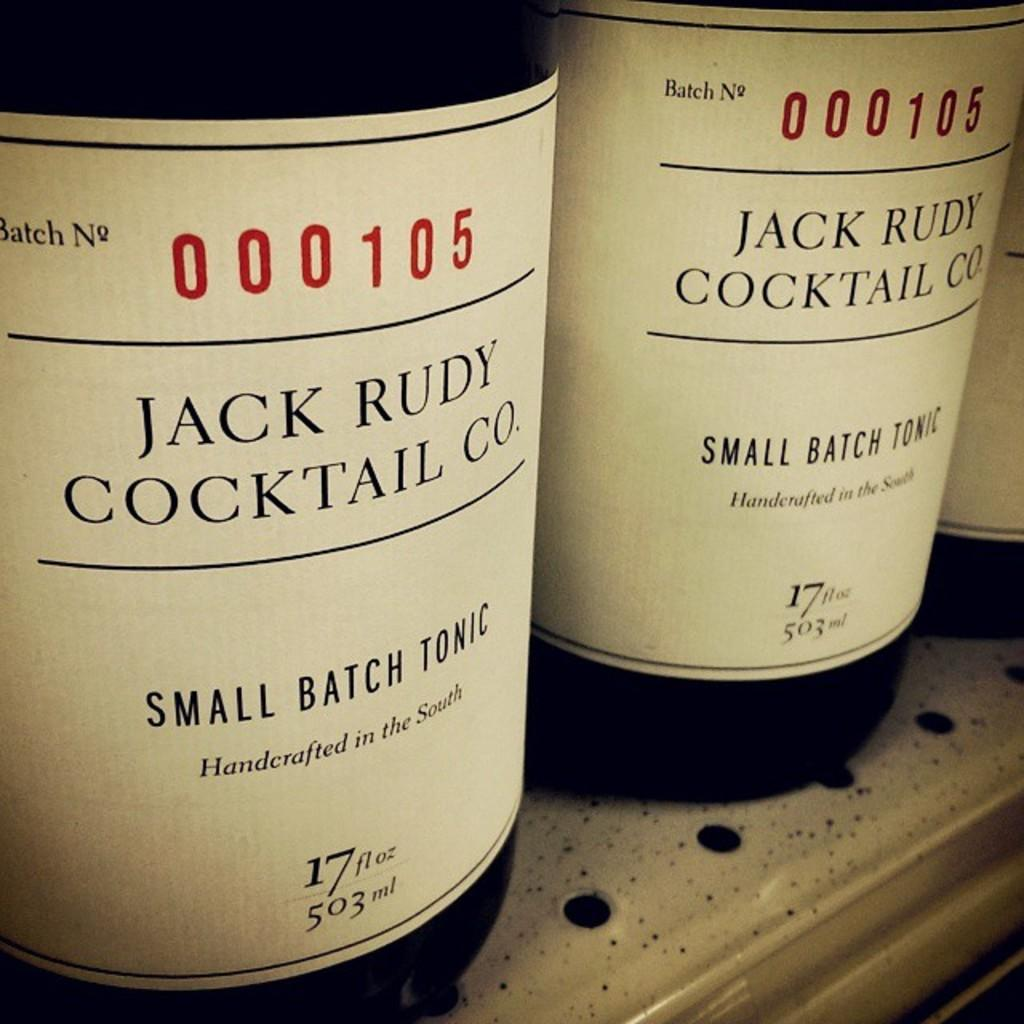Provide a one-sentence caption for the provided image. Bottles of Jack Rudy Cocktail co. small batch tonic are on the shelf. 